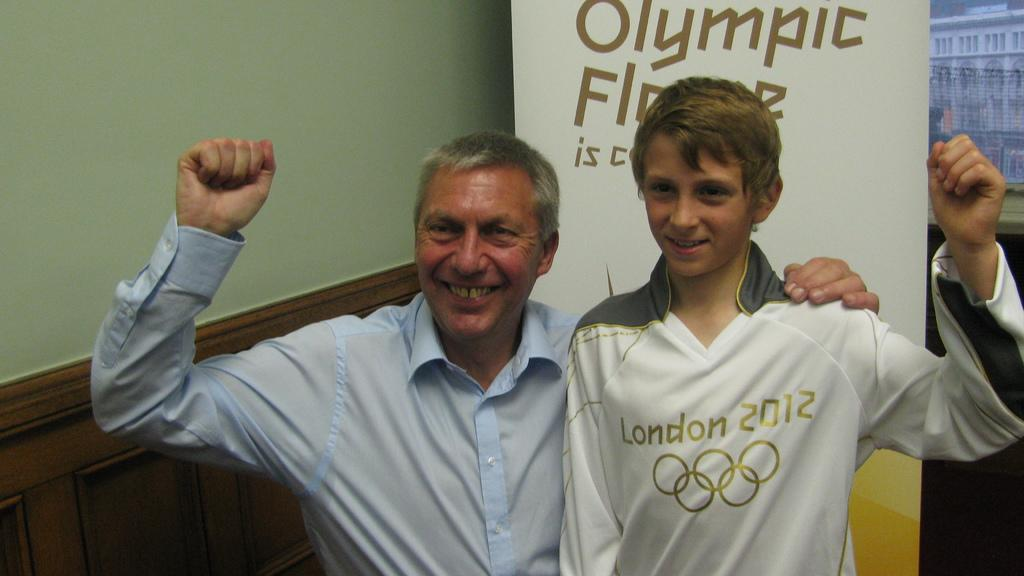How many people are in the image? There are two persons in the image. What can be seen near the wall in the image? There is a banner with text near the wall in the image. What type of structure is visible in the image? There is a building visible in the image. How many fish are swimming in the lamp in the image? There are no fish or lamps present in the image. 